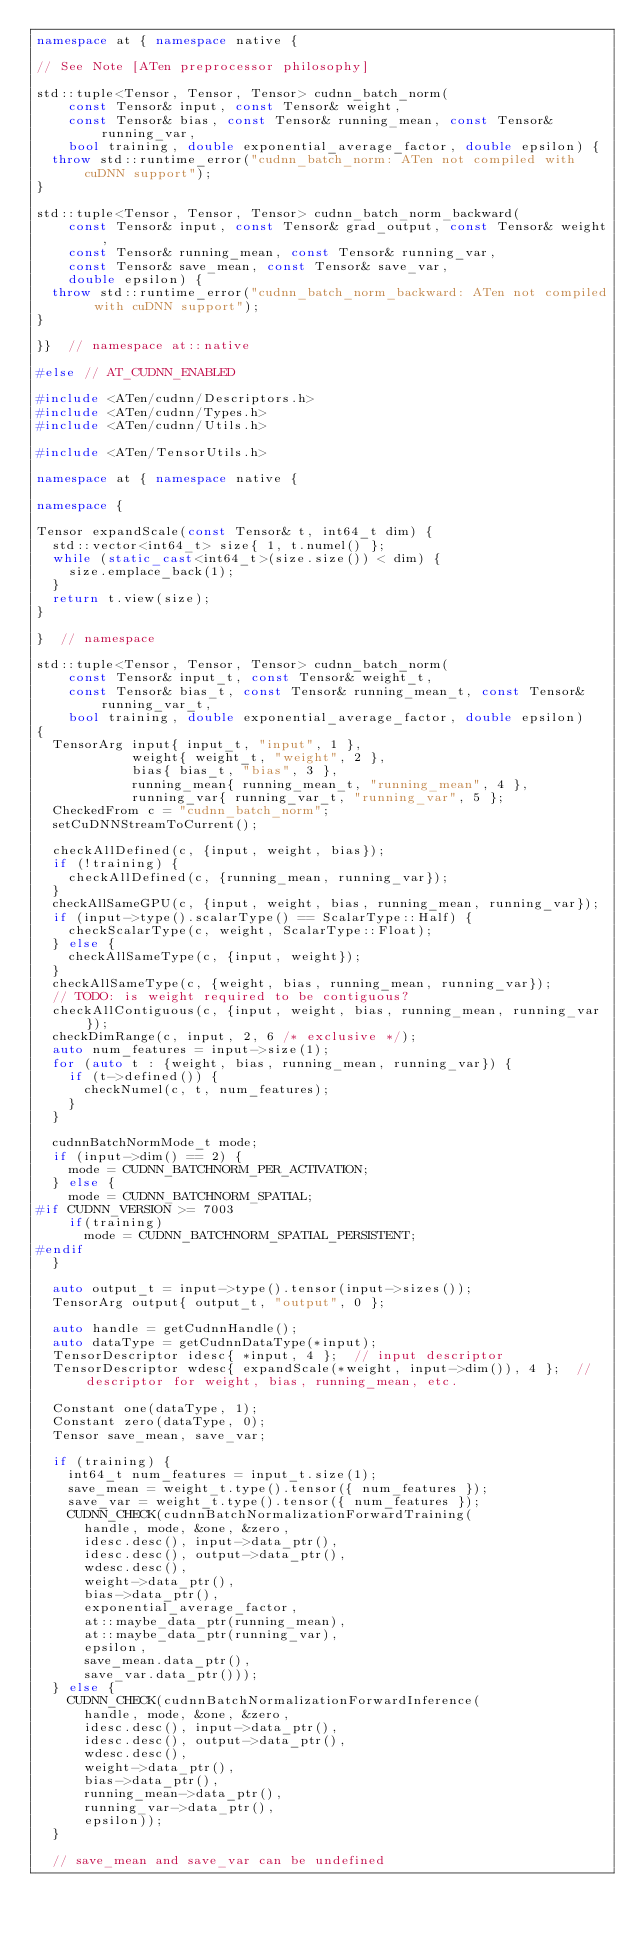<code> <loc_0><loc_0><loc_500><loc_500><_C++_>namespace at { namespace native {

// See Note [ATen preprocessor philosophy]

std::tuple<Tensor, Tensor, Tensor> cudnn_batch_norm(
    const Tensor& input, const Tensor& weight,
    const Tensor& bias, const Tensor& running_mean, const Tensor& running_var,
    bool training, double exponential_average_factor, double epsilon) {
  throw std::runtime_error("cudnn_batch_norm: ATen not compiled with cuDNN support");
}

std::tuple<Tensor, Tensor, Tensor> cudnn_batch_norm_backward(
    const Tensor& input, const Tensor& grad_output, const Tensor& weight,
    const Tensor& running_mean, const Tensor& running_var,
    const Tensor& save_mean, const Tensor& save_var,
    double epsilon) {
  throw std::runtime_error("cudnn_batch_norm_backward: ATen not compiled with cuDNN support");
}

}}  // namespace at::native

#else // AT_CUDNN_ENABLED

#include <ATen/cudnn/Descriptors.h>
#include <ATen/cudnn/Types.h>
#include <ATen/cudnn/Utils.h>

#include <ATen/TensorUtils.h>

namespace at { namespace native {

namespace {

Tensor expandScale(const Tensor& t, int64_t dim) {
  std::vector<int64_t> size{ 1, t.numel() };
  while (static_cast<int64_t>(size.size()) < dim) {
    size.emplace_back(1);
  }
  return t.view(size);
}

}  // namespace

std::tuple<Tensor, Tensor, Tensor> cudnn_batch_norm(
    const Tensor& input_t, const Tensor& weight_t,
    const Tensor& bias_t, const Tensor& running_mean_t, const Tensor& running_var_t,
    bool training, double exponential_average_factor, double epsilon)
{
  TensorArg input{ input_t, "input", 1 },
            weight{ weight_t, "weight", 2 },
            bias{ bias_t, "bias", 3 },
            running_mean{ running_mean_t, "running_mean", 4 },
            running_var{ running_var_t, "running_var", 5 };
  CheckedFrom c = "cudnn_batch_norm";
  setCuDNNStreamToCurrent();

  checkAllDefined(c, {input, weight, bias});
  if (!training) {
    checkAllDefined(c, {running_mean, running_var});
  }
  checkAllSameGPU(c, {input, weight, bias, running_mean, running_var});
  if (input->type().scalarType() == ScalarType::Half) {
    checkScalarType(c, weight, ScalarType::Float);
  } else {
    checkAllSameType(c, {input, weight});
  }
  checkAllSameType(c, {weight, bias, running_mean, running_var});
  // TODO: is weight required to be contiguous?
  checkAllContiguous(c, {input, weight, bias, running_mean, running_var});
  checkDimRange(c, input, 2, 6 /* exclusive */);
  auto num_features = input->size(1);
  for (auto t : {weight, bias, running_mean, running_var}) {
    if (t->defined()) {
      checkNumel(c, t, num_features);
    }
  }

  cudnnBatchNormMode_t mode;
  if (input->dim() == 2) {
    mode = CUDNN_BATCHNORM_PER_ACTIVATION;
  } else {
    mode = CUDNN_BATCHNORM_SPATIAL;
#if CUDNN_VERSION >= 7003
    if(training)
      mode = CUDNN_BATCHNORM_SPATIAL_PERSISTENT;
#endif
  }

  auto output_t = input->type().tensor(input->sizes());
  TensorArg output{ output_t, "output", 0 };

  auto handle = getCudnnHandle();
  auto dataType = getCudnnDataType(*input);
  TensorDescriptor idesc{ *input, 4 };  // input descriptor
  TensorDescriptor wdesc{ expandScale(*weight, input->dim()), 4 };  // descriptor for weight, bias, running_mean, etc.

  Constant one(dataType, 1);
  Constant zero(dataType, 0);
  Tensor save_mean, save_var;

  if (training) {
    int64_t num_features = input_t.size(1);
    save_mean = weight_t.type().tensor({ num_features });
    save_var = weight_t.type().tensor({ num_features });
    CUDNN_CHECK(cudnnBatchNormalizationForwardTraining(
      handle, mode, &one, &zero,
      idesc.desc(), input->data_ptr(),
      idesc.desc(), output->data_ptr(),
      wdesc.desc(),
      weight->data_ptr(),
      bias->data_ptr(),
      exponential_average_factor,
      at::maybe_data_ptr(running_mean),
      at::maybe_data_ptr(running_var),
      epsilon,
      save_mean.data_ptr(),
      save_var.data_ptr()));
  } else {
    CUDNN_CHECK(cudnnBatchNormalizationForwardInference(
      handle, mode, &one, &zero,
      idesc.desc(), input->data_ptr(),
      idesc.desc(), output->data_ptr(),
      wdesc.desc(),
      weight->data_ptr(),
      bias->data_ptr(),
      running_mean->data_ptr(),
      running_var->data_ptr(),
      epsilon));
  }

  // save_mean and save_var can be undefined</code> 